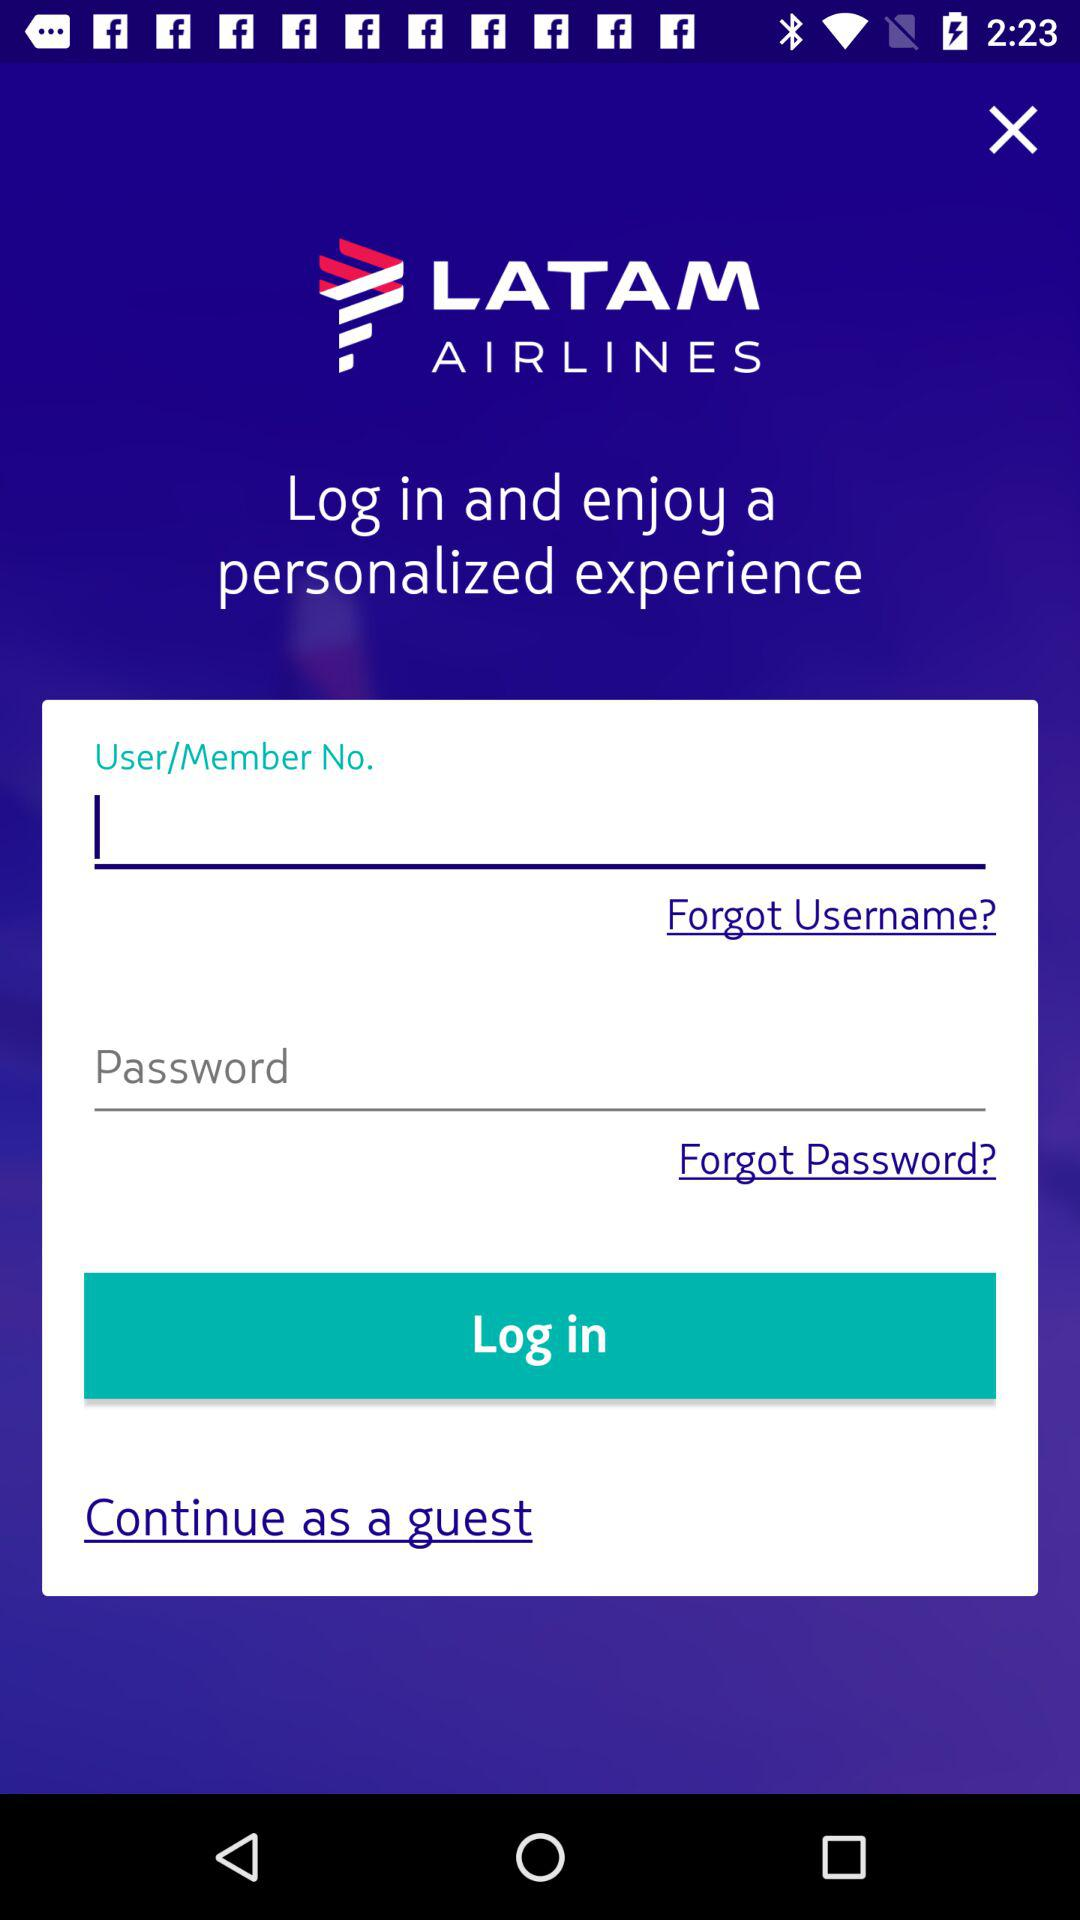How can we continue without logging in? You can continue as a guest. 